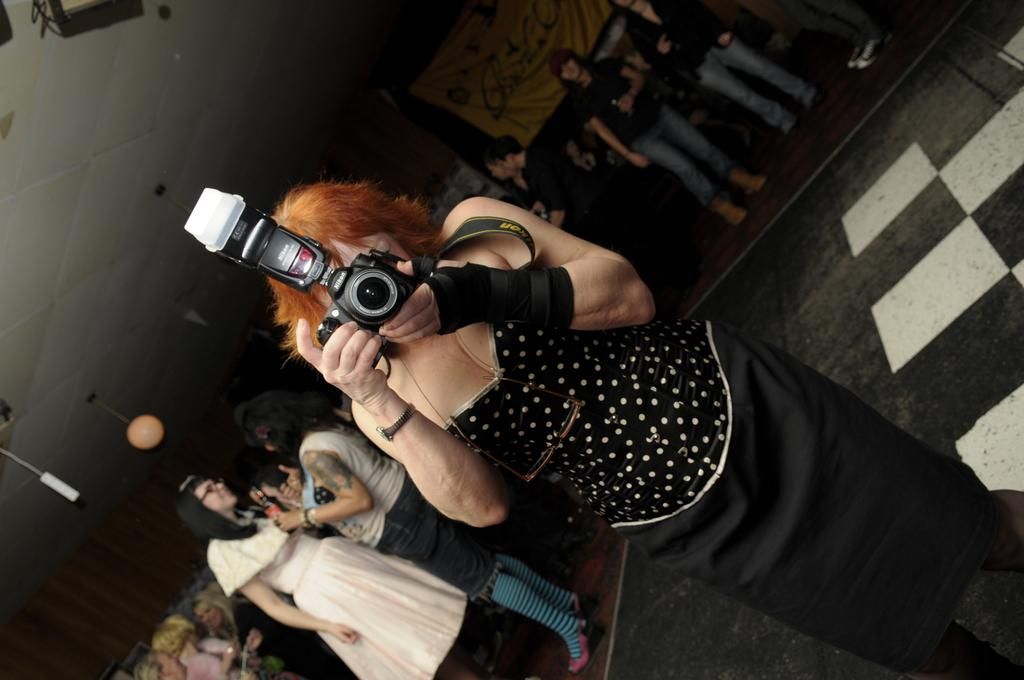What is the person at the front of the image doing? The person is standing at the front in the image and is holding a camera. What is the person wearing? The person is wearing a black dress. Are there any other people visible in the image? Yes, there are other people behind the person in the image. What can be seen at the center back of the image? There is a banner at the center back of the image. What type of animal can be seen flying in the image? There is no animal visible in the image, let alone one that can fly. 